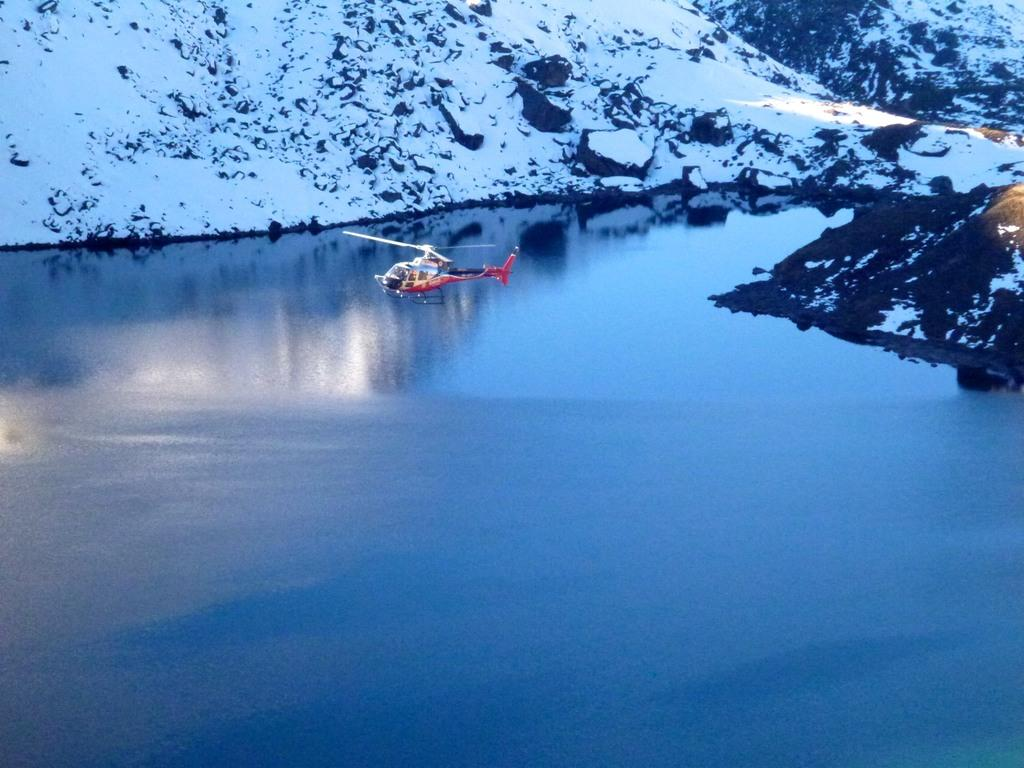What is the main subject of the image? The main subject of the image is a helicopter. What is the helicopter doing in the image? The helicopter is flying above the water in the image. What can be seen in the background of the image? There are snowy mountains in the background of the image. What type of tax is being collected from the loaf of bread in the image? There is no loaf of bread or tax mentioned in the image; it features a helicopter flying above the water with snowy mountains in the background. 